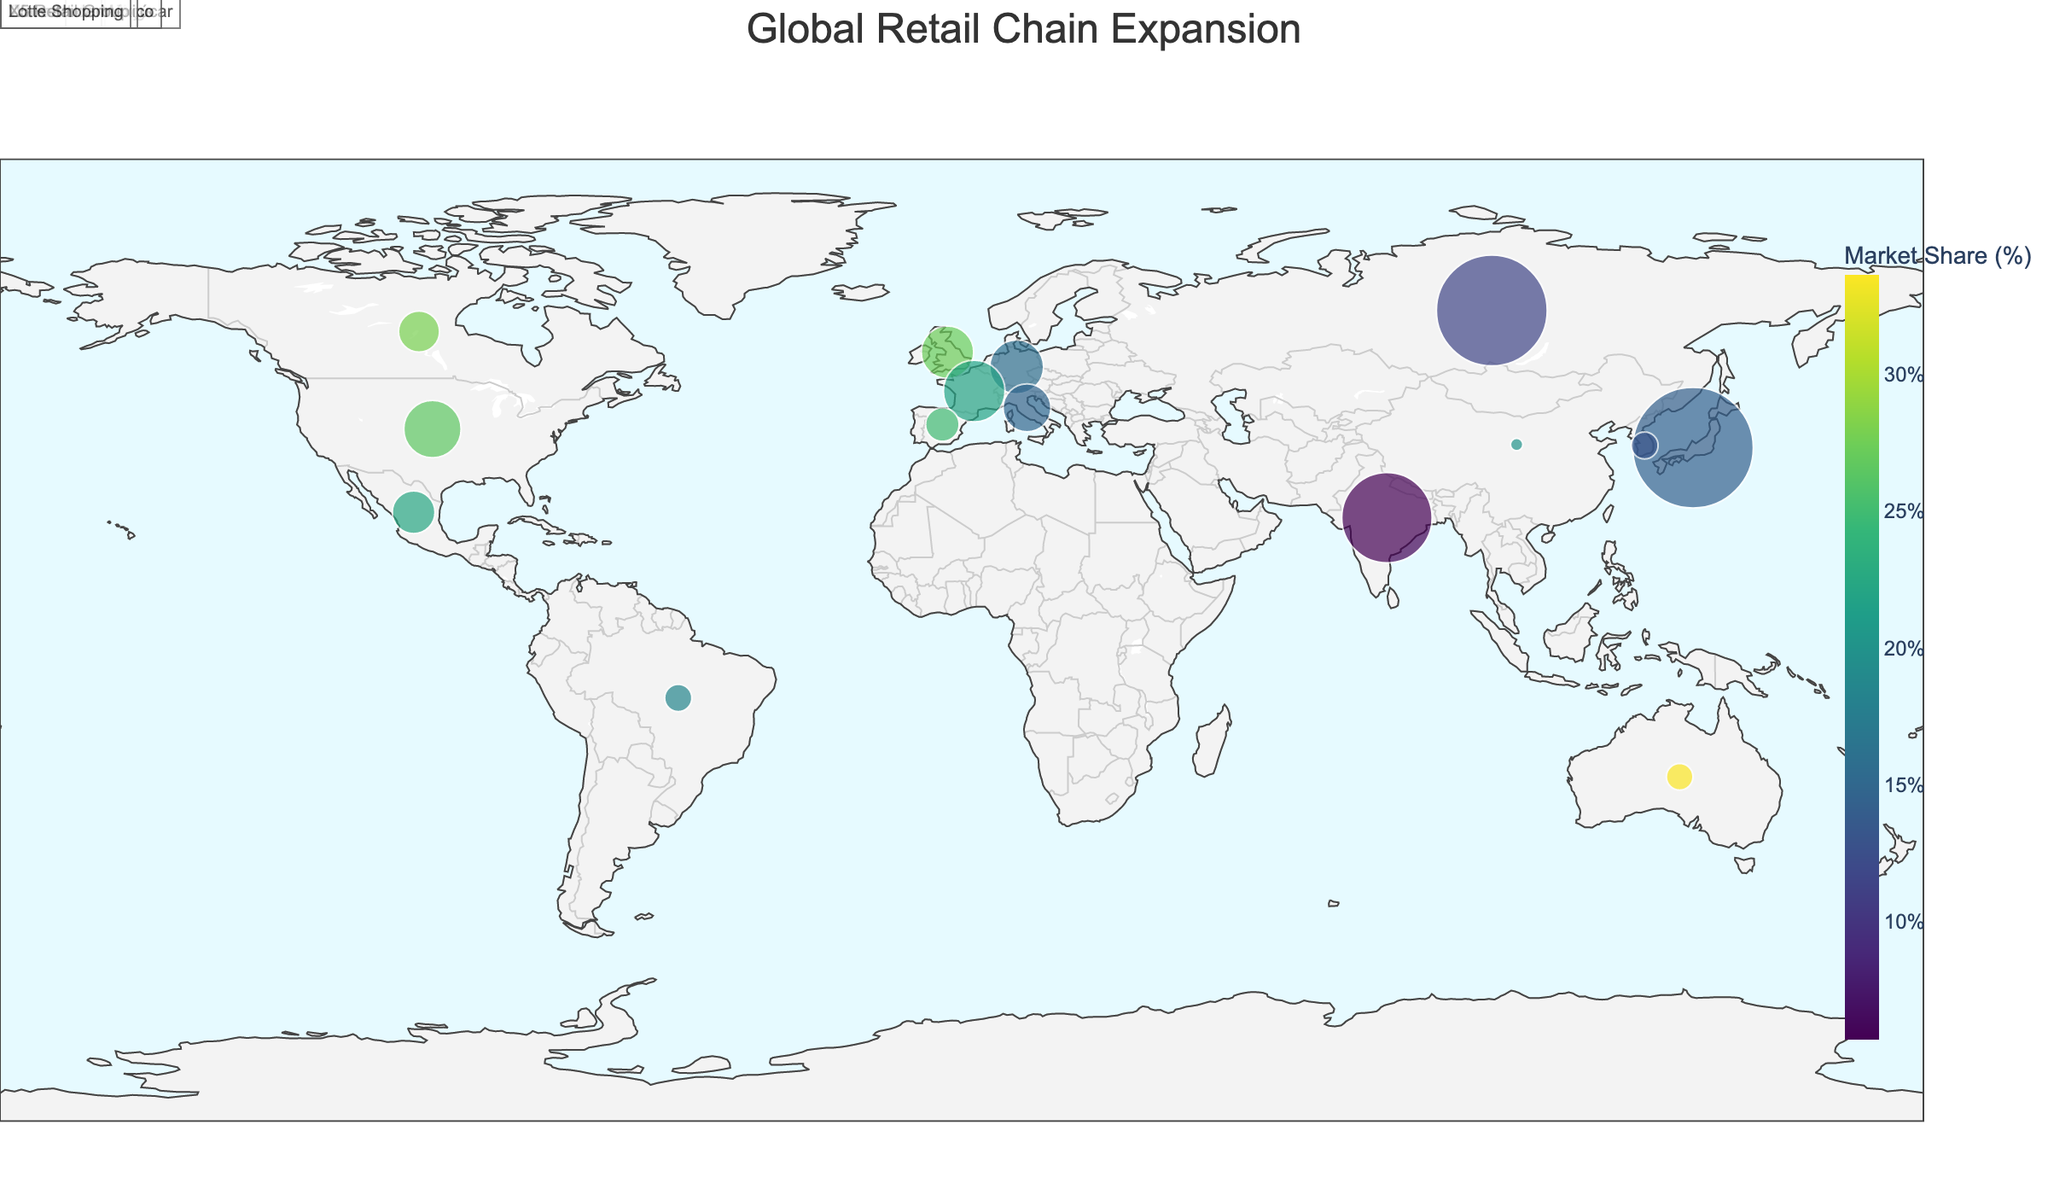Which country has the highest market share for its retail chain? The figure shows the market share by color intensity. The highest intensity color represents the highest market share. By observing the colors, Australia (Woolworths) has the highest market share at 33.6%.
Answer: Australia Which retail chain has the most stores globally? The figure depicts store counts by the size of the markers. The largest marker represents the highest store count. Japan (Seven & I Holdings) has the largest marker, indicating the highest store count of 20,939.
Answer: Seven & I Holdings What is the total number of stores in the United States and Mexico combined? By examining the sizes of the markers and referring to the data, the store count for the United States (Walmart) is 4,743 and for Mexico (Walmart de México) is 2,634. Adding them, 4,743 + 2,634 = 7,377.
Answer: 7,377 How does the market share of Mercadona in Spain compare to that of Tesco in the United Kingdom? The figure uses color to represent market share. By comparing the colors of Spain and the United Kingdom, and referring to the data, Mercadona has a 24.9% market share, while Tesco has a 27.3% market share. Thus, Tesco has a higher market share.
Answer: Tesco has a higher market share Which country has the smallest market share for its retail chain? The country with the lightest color intensity represents the smallest market share. India (Reliance Retail) has the lightest color, indicating a market share of 5.7%, which is the smallest among the listed countries.
Answer: India What is the difference in market share between Carrefour in France and Alibaba in China? By referring to the colors and the data, Carrefour's market share in France is 22.0%, and Alibaba's market share in China is 20.1%. The difference is 22.0% - 20.1% = 1.9%.
Answer: 1.9% Which country has the most evenly matched store count and market share? By comparing both store count and market share visually, Germany (Aldi) appears to have a balanced representation with significant store count (4,184) and a moderate market share (15.8%).
Answer: Germany How many countries have a market share above 20%? By observing the colors that exceed the threshold and verifying with the data, countries with market share above 20% are the United States, United Kingdom, France, Canada, and Spain. Counting these, there are 5 countries.
Answer: 5 What is the average market share of the retail chains in North America? North America consists of the United States, Canada, and Mexico. The market shares are USA (26.5%), Canada (27.9%), and Mexico (22.3%). The average is (26.5 + 27.9 + 22.3) / 3 = 25.57%.
Answer: 25.57% Which retail chain has more stores: Lotte Shopping in South Korea or Woolworths in Australia? Checking the size of the markers, Lotte Shopping in South Korea has 1,047 stores, and Woolworths in Australia has 1,024 stores. Lotte Shopping has more stores.
Answer: Lotte Shopping 